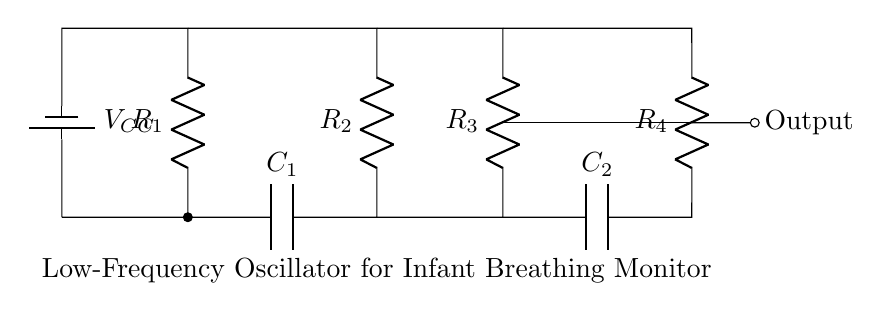What type of components are used in this oscillator circuit? The circuit contains resistors, capacitors, an operational amplifier, and a battery. These components are typical in oscillator circuits for generating signals.
Answer: resistors, capacitors, operational amplifier, battery What is the function of the operational amplifier in this circuit? The operational amplifier amplifies the oscillating signal produced by the combination of resistors and capacitors, which is crucial in an oscillator to ensure the output signal is strong enough for monitoring.
Answer: amplifies the oscillating signal How many resistors are there in this circuit? Counting the visual representation of the diagram yields four distinct resistors labeled R1, R2, R3, and R4.
Answer: four What is the role of capacitors in this low-frequency oscillator? Capacitors, specifically C1 and C2, are essential for setting the frequency of oscillation in conjunction with the resistors by charging and discharging, affecting the timing of the output signal.
Answer: setting frequency What is the primary function of this circuit? The main purpose of this low-frequency oscillator circuit is to monitor infant breathing by generating an output signal that corresponds to the breathing pattern, which is vital for pediatric health applications.
Answer: monitor infant breathing What could happen if the values of resistors or capacitors are changed in this oscillator? Altering the values will affect the frequency of the oscillation; if resistors increase, oscillation frequency decreases, and vice versa, impacting the circuit's effectiveness in monitoring breathing patterns.
Answer: change oscillation frequency 